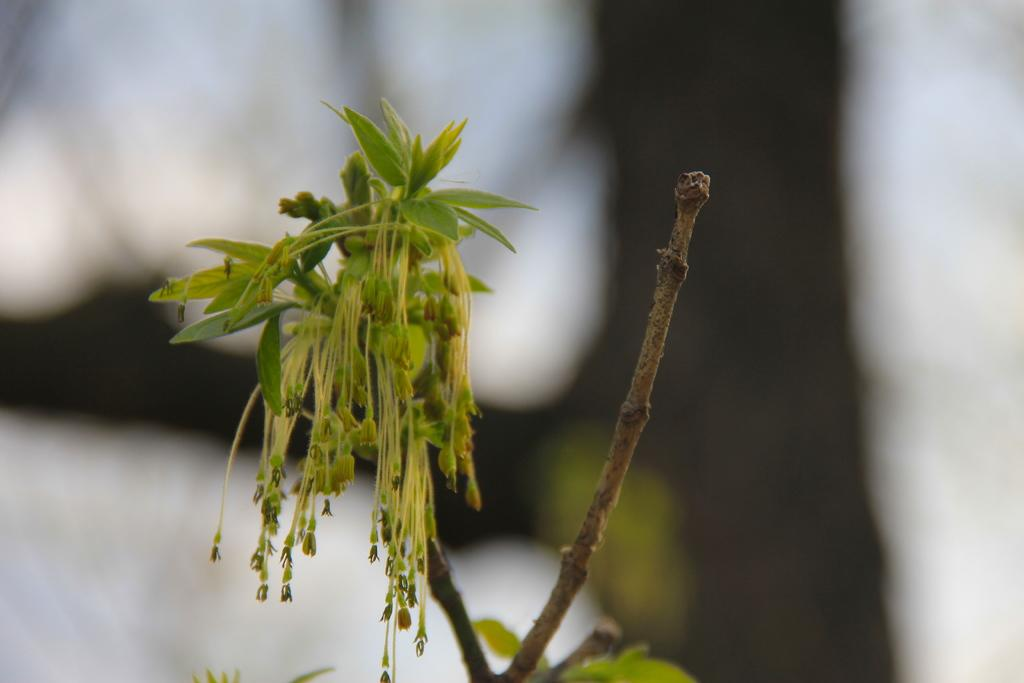What type of plant is in the image? There is a houseplant in the image. What type of bottle is visible in the image? There is no bottle present in the image; it only features a houseplant. 